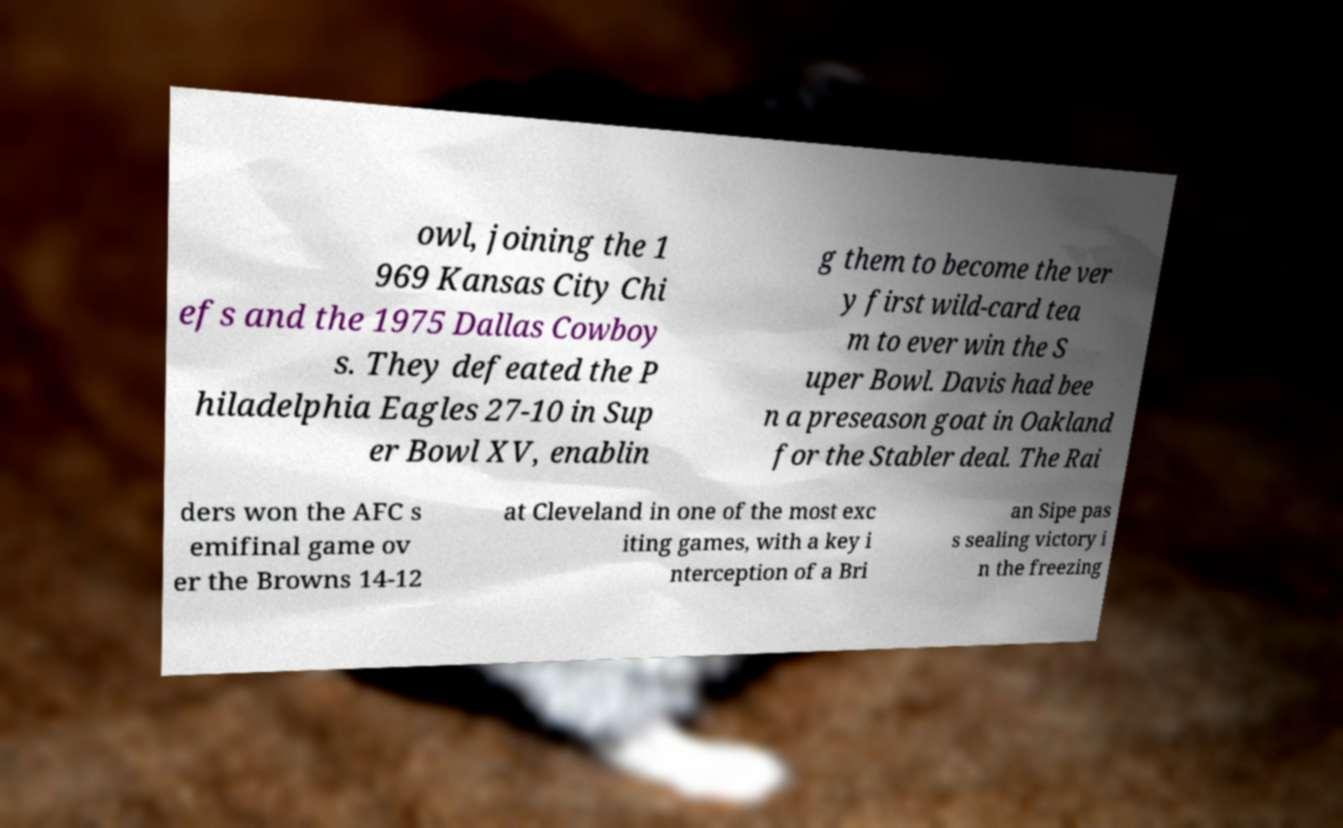What messages or text are displayed in this image? I need them in a readable, typed format. owl, joining the 1 969 Kansas City Chi efs and the 1975 Dallas Cowboy s. They defeated the P hiladelphia Eagles 27-10 in Sup er Bowl XV, enablin g them to become the ver y first wild-card tea m to ever win the S uper Bowl. Davis had bee n a preseason goat in Oakland for the Stabler deal. The Rai ders won the AFC s emifinal game ov er the Browns 14-12 at Cleveland in one of the most exc iting games, with a key i nterception of a Bri an Sipe pas s sealing victory i n the freezing 